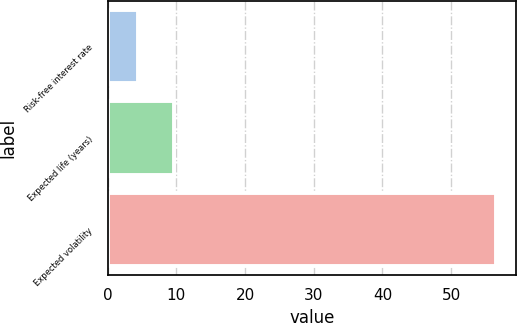Convert chart to OTSL. <chart><loc_0><loc_0><loc_500><loc_500><bar_chart><fcel>Risk-free interest rate<fcel>Expected life (years)<fcel>Expected volatility<nl><fcel>4.38<fcel>9.6<fcel>56.6<nl></chart> 